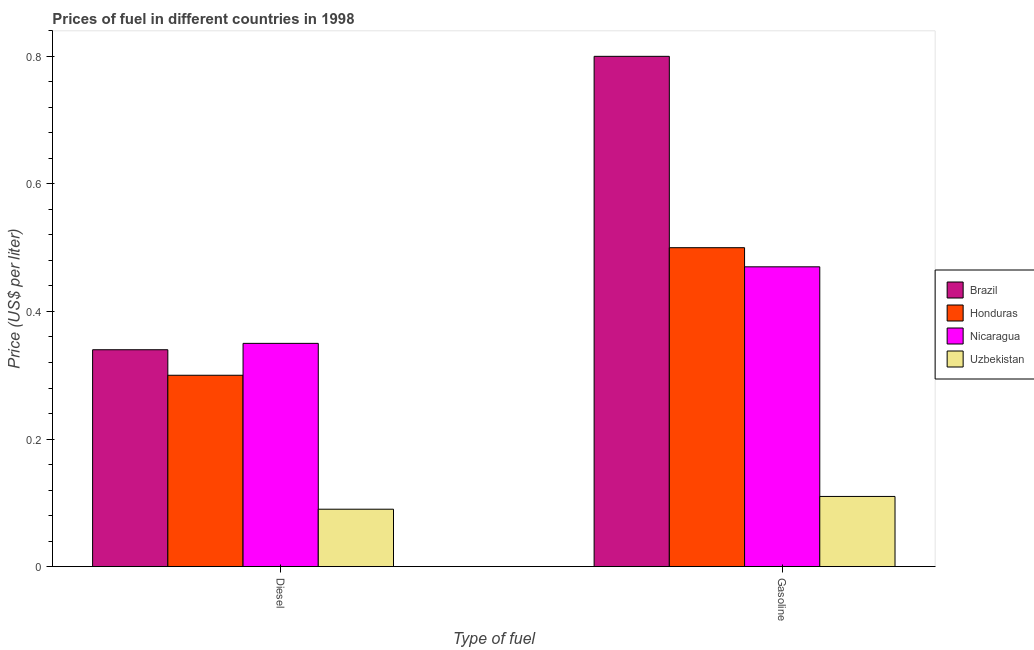How many groups of bars are there?
Your answer should be very brief. 2. Are the number of bars per tick equal to the number of legend labels?
Your response must be concise. Yes. How many bars are there on the 2nd tick from the left?
Keep it short and to the point. 4. What is the label of the 1st group of bars from the left?
Provide a short and direct response. Diesel. What is the diesel price in Brazil?
Provide a short and direct response. 0.34. Across all countries, what is the maximum diesel price?
Keep it short and to the point. 0.35. Across all countries, what is the minimum diesel price?
Offer a terse response. 0.09. In which country was the diesel price maximum?
Your answer should be very brief. Nicaragua. In which country was the gasoline price minimum?
Your answer should be compact. Uzbekistan. What is the difference between the gasoline price in Honduras and that in Brazil?
Keep it short and to the point. -0.3. What is the difference between the diesel price in Uzbekistan and the gasoline price in Nicaragua?
Your answer should be very brief. -0.38. What is the average gasoline price per country?
Provide a succinct answer. 0.47. What is the difference between the gasoline price and diesel price in Nicaragua?
Ensure brevity in your answer.  0.12. What is the ratio of the gasoline price in Brazil to that in Uzbekistan?
Your answer should be compact. 7.27. What does the 2nd bar from the left in Gasoline represents?
Your response must be concise. Honduras. What does the 1st bar from the right in Gasoline represents?
Provide a succinct answer. Uzbekistan. Are all the bars in the graph horizontal?
Your response must be concise. No. How many countries are there in the graph?
Keep it short and to the point. 4. Are the values on the major ticks of Y-axis written in scientific E-notation?
Keep it short and to the point. No. Does the graph contain any zero values?
Provide a succinct answer. No. Does the graph contain grids?
Offer a terse response. No. How many legend labels are there?
Offer a very short reply. 4. How are the legend labels stacked?
Your answer should be compact. Vertical. What is the title of the graph?
Keep it short and to the point. Prices of fuel in different countries in 1998. What is the label or title of the X-axis?
Keep it short and to the point. Type of fuel. What is the label or title of the Y-axis?
Your response must be concise. Price (US$ per liter). What is the Price (US$ per liter) of Brazil in Diesel?
Offer a terse response. 0.34. What is the Price (US$ per liter) in Honduras in Diesel?
Your answer should be very brief. 0.3. What is the Price (US$ per liter) of Nicaragua in Diesel?
Give a very brief answer. 0.35. What is the Price (US$ per liter) of Uzbekistan in Diesel?
Provide a succinct answer. 0.09. What is the Price (US$ per liter) of Honduras in Gasoline?
Keep it short and to the point. 0.5. What is the Price (US$ per liter) in Nicaragua in Gasoline?
Provide a succinct answer. 0.47. What is the Price (US$ per liter) of Uzbekistan in Gasoline?
Offer a terse response. 0.11. Across all Type of fuel, what is the maximum Price (US$ per liter) in Brazil?
Your answer should be compact. 0.8. Across all Type of fuel, what is the maximum Price (US$ per liter) of Honduras?
Offer a terse response. 0.5. Across all Type of fuel, what is the maximum Price (US$ per liter) in Nicaragua?
Your response must be concise. 0.47. Across all Type of fuel, what is the maximum Price (US$ per liter) of Uzbekistan?
Make the answer very short. 0.11. Across all Type of fuel, what is the minimum Price (US$ per liter) of Brazil?
Your response must be concise. 0.34. Across all Type of fuel, what is the minimum Price (US$ per liter) of Honduras?
Your response must be concise. 0.3. Across all Type of fuel, what is the minimum Price (US$ per liter) of Uzbekistan?
Keep it short and to the point. 0.09. What is the total Price (US$ per liter) in Brazil in the graph?
Your answer should be very brief. 1.14. What is the total Price (US$ per liter) of Nicaragua in the graph?
Your answer should be compact. 0.82. What is the total Price (US$ per liter) of Uzbekistan in the graph?
Give a very brief answer. 0.2. What is the difference between the Price (US$ per liter) in Brazil in Diesel and that in Gasoline?
Provide a short and direct response. -0.46. What is the difference between the Price (US$ per liter) in Nicaragua in Diesel and that in Gasoline?
Keep it short and to the point. -0.12. What is the difference between the Price (US$ per liter) of Uzbekistan in Diesel and that in Gasoline?
Provide a short and direct response. -0.02. What is the difference between the Price (US$ per liter) of Brazil in Diesel and the Price (US$ per liter) of Honduras in Gasoline?
Provide a short and direct response. -0.16. What is the difference between the Price (US$ per liter) of Brazil in Diesel and the Price (US$ per liter) of Nicaragua in Gasoline?
Your answer should be very brief. -0.13. What is the difference between the Price (US$ per liter) in Brazil in Diesel and the Price (US$ per liter) in Uzbekistan in Gasoline?
Make the answer very short. 0.23. What is the difference between the Price (US$ per liter) in Honduras in Diesel and the Price (US$ per liter) in Nicaragua in Gasoline?
Make the answer very short. -0.17. What is the difference between the Price (US$ per liter) of Honduras in Diesel and the Price (US$ per liter) of Uzbekistan in Gasoline?
Make the answer very short. 0.19. What is the difference between the Price (US$ per liter) of Nicaragua in Diesel and the Price (US$ per liter) of Uzbekistan in Gasoline?
Keep it short and to the point. 0.24. What is the average Price (US$ per liter) of Brazil per Type of fuel?
Make the answer very short. 0.57. What is the average Price (US$ per liter) in Nicaragua per Type of fuel?
Provide a short and direct response. 0.41. What is the average Price (US$ per liter) of Uzbekistan per Type of fuel?
Offer a terse response. 0.1. What is the difference between the Price (US$ per liter) of Brazil and Price (US$ per liter) of Honduras in Diesel?
Keep it short and to the point. 0.04. What is the difference between the Price (US$ per liter) in Brazil and Price (US$ per liter) in Nicaragua in Diesel?
Make the answer very short. -0.01. What is the difference between the Price (US$ per liter) in Brazil and Price (US$ per liter) in Uzbekistan in Diesel?
Your answer should be compact. 0.25. What is the difference between the Price (US$ per liter) of Honduras and Price (US$ per liter) of Nicaragua in Diesel?
Your response must be concise. -0.05. What is the difference between the Price (US$ per liter) in Honduras and Price (US$ per liter) in Uzbekistan in Diesel?
Your answer should be compact. 0.21. What is the difference between the Price (US$ per liter) of Nicaragua and Price (US$ per liter) of Uzbekistan in Diesel?
Provide a succinct answer. 0.26. What is the difference between the Price (US$ per liter) in Brazil and Price (US$ per liter) in Nicaragua in Gasoline?
Keep it short and to the point. 0.33. What is the difference between the Price (US$ per liter) in Brazil and Price (US$ per liter) in Uzbekistan in Gasoline?
Provide a short and direct response. 0.69. What is the difference between the Price (US$ per liter) of Honduras and Price (US$ per liter) of Uzbekistan in Gasoline?
Your answer should be compact. 0.39. What is the difference between the Price (US$ per liter) in Nicaragua and Price (US$ per liter) in Uzbekistan in Gasoline?
Keep it short and to the point. 0.36. What is the ratio of the Price (US$ per liter) of Brazil in Diesel to that in Gasoline?
Your answer should be very brief. 0.42. What is the ratio of the Price (US$ per liter) in Honduras in Diesel to that in Gasoline?
Your response must be concise. 0.6. What is the ratio of the Price (US$ per liter) in Nicaragua in Diesel to that in Gasoline?
Your answer should be compact. 0.74. What is the ratio of the Price (US$ per liter) in Uzbekistan in Diesel to that in Gasoline?
Offer a terse response. 0.82. What is the difference between the highest and the second highest Price (US$ per liter) of Brazil?
Ensure brevity in your answer.  0.46. What is the difference between the highest and the second highest Price (US$ per liter) in Nicaragua?
Give a very brief answer. 0.12. What is the difference between the highest and the lowest Price (US$ per liter) of Brazil?
Give a very brief answer. 0.46. What is the difference between the highest and the lowest Price (US$ per liter) in Honduras?
Provide a short and direct response. 0.2. What is the difference between the highest and the lowest Price (US$ per liter) in Nicaragua?
Offer a terse response. 0.12. What is the difference between the highest and the lowest Price (US$ per liter) in Uzbekistan?
Provide a short and direct response. 0.02. 